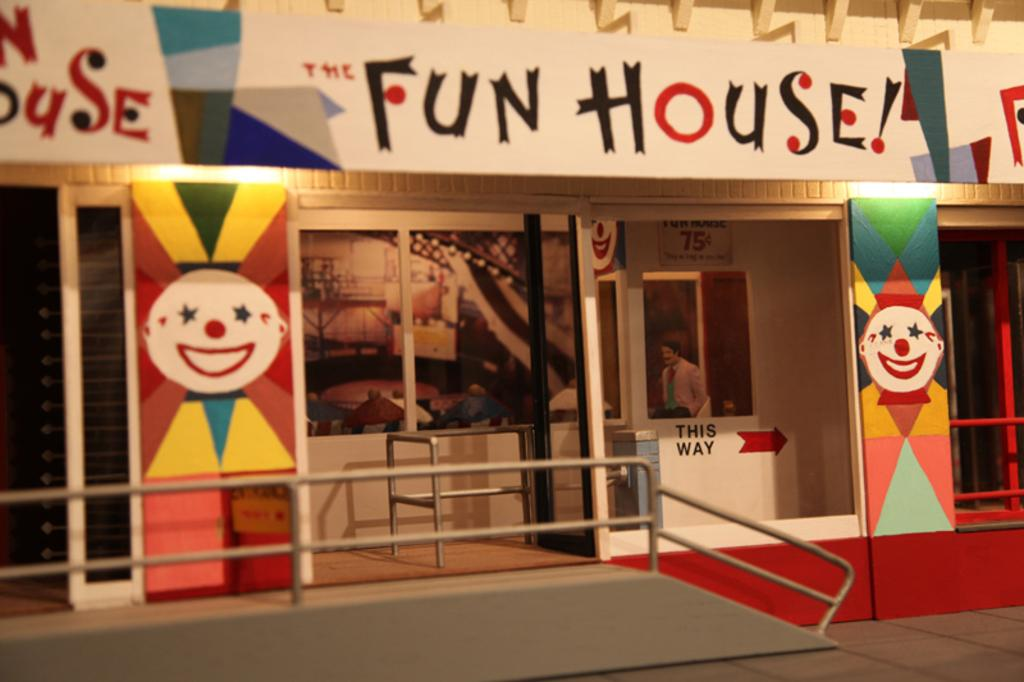Provide a one-sentence caption for the provided image. The front of a building that is called fun house. 